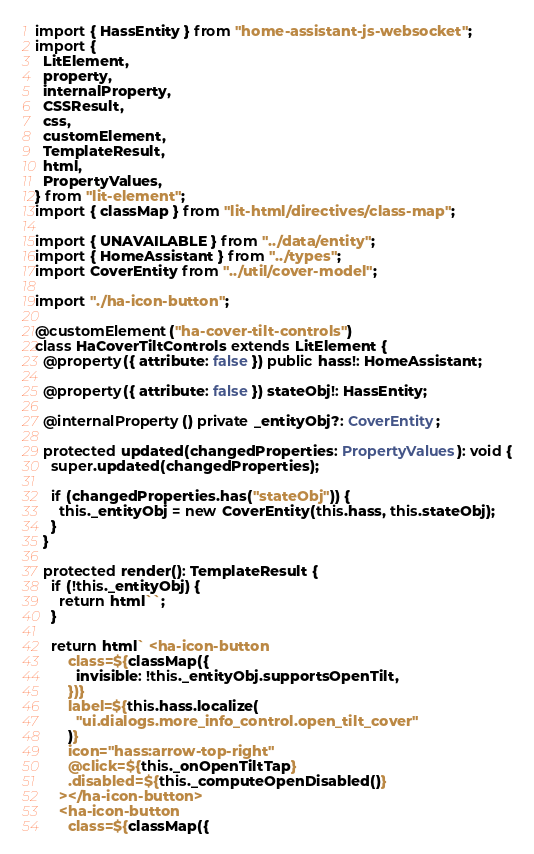<code> <loc_0><loc_0><loc_500><loc_500><_TypeScript_>import { HassEntity } from "home-assistant-js-websocket";
import {
  LitElement,
  property,
  internalProperty,
  CSSResult,
  css,
  customElement,
  TemplateResult,
  html,
  PropertyValues,
} from "lit-element";
import { classMap } from "lit-html/directives/class-map";

import { UNAVAILABLE } from "../data/entity";
import { HomeAssistant } from "../types";
import CoverEntity from "../util/cover-model";

import "./ha-icon-button";

@customElement("ha-cover-tilt-controls")
class HaCoverTiltControls extends LitElement {
  @property({ attribute: false }) public hass!: HomeAssistant;

  @property({ attribute: false }) stateObj!: HassEntity;

  @internalProperty() private _entityObj?: CoverEntity;

  protected updated(changedProperties: PropertyValues): void {
    super.updated(changedProperties);

    if (changedProperties.has("stateObj")) {
      this._entityObj = new CoverEntity(this.hass, this.stateObj);
    }
  }

  protected render(): TemplateResult {
    if (!this._entityObj) {
      return html``;
    }

    return html` <ha-icon-button
        class=${classMap({
          invisible: !this._entityObj.supportsOpenTilt,
        })}
        label=${this.hass.localize(
          "ui.dialogs.more_info_control.open_tilt_cover"
        )}
        icon="hass:arrow-top-right"
        @click=${this._onOpenTiltTap}
        .disabled=${this._computeOpenDisabled()}
      ></ha-icon-button>
      <ha-icon-button
        class=${classMap({</code> 